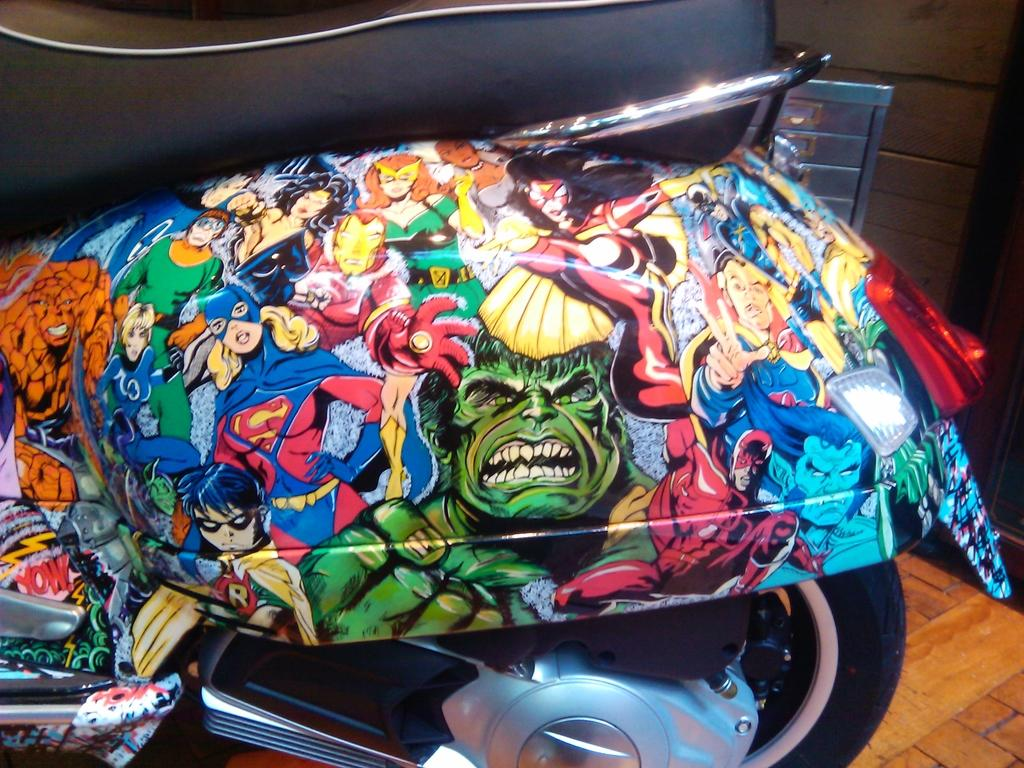What is the main object in the image? There is a bike in the image. What is the color of the bike? The bike is black in color. Are there any decorations on the bike? Yes, there are cartoon pictures on the bike. What is on the back side of the bike? There is a brown color board on the back side of the bike. Can you tell me what news is being broadcasted on the bike? There is no news broadcast on the bike; it is a bike with cartoon pictures and a brown color board on the back side. Is there a snail crawling on the bike in the image? There is no snail present on the bike in the image. 